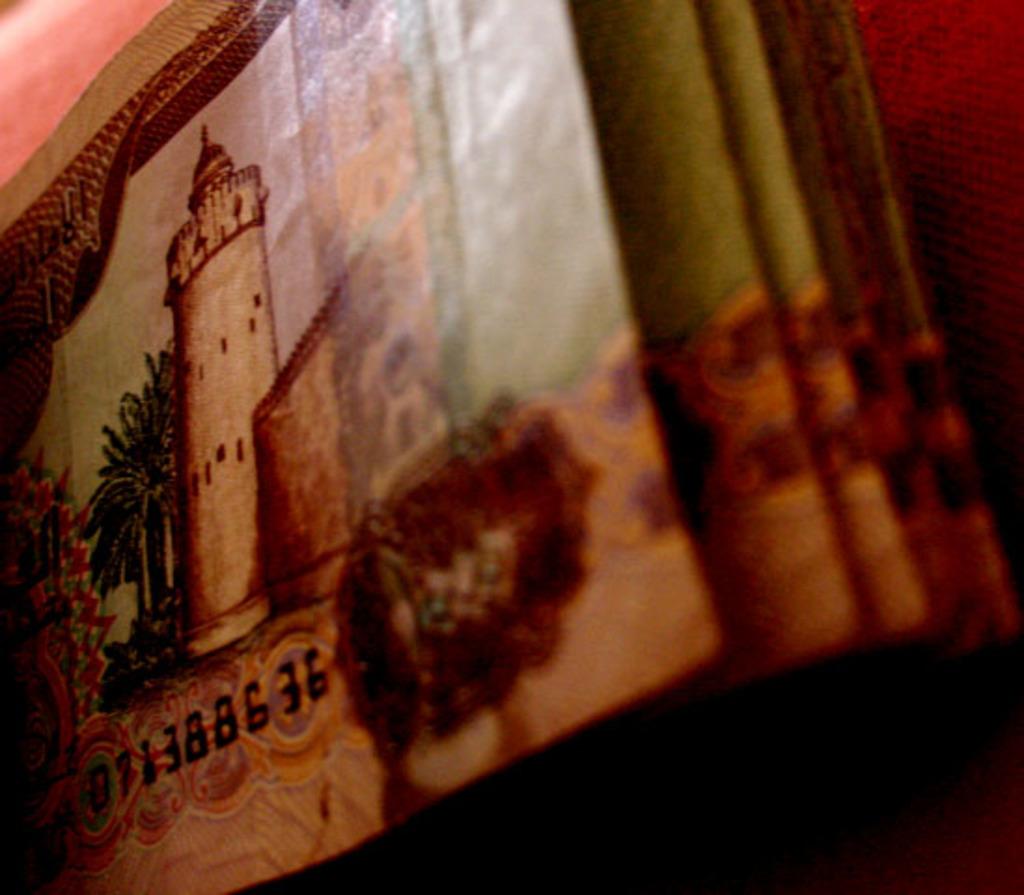What is the serial number on this image?
Your response must be concise. 071388636. What is the number shown on the bottom left?
Your response must be concise. 071388636. 